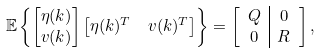<formula> <loc_0><loc_0><loc_500><loc_500>\mathbb { E } & \left \{ \begin{bmatrix} \eta ( k ) \\ v ( k ) \end{bmatrix} \begin{bmatrix} \eta ( k ) ^ { T } & v ( k ) ^ { T } \end{bmatrix} \right \} = \left [ \begin{array} { c | c } Q & 0 \\ 0 & R \end{array} \right ] ,</formula> 